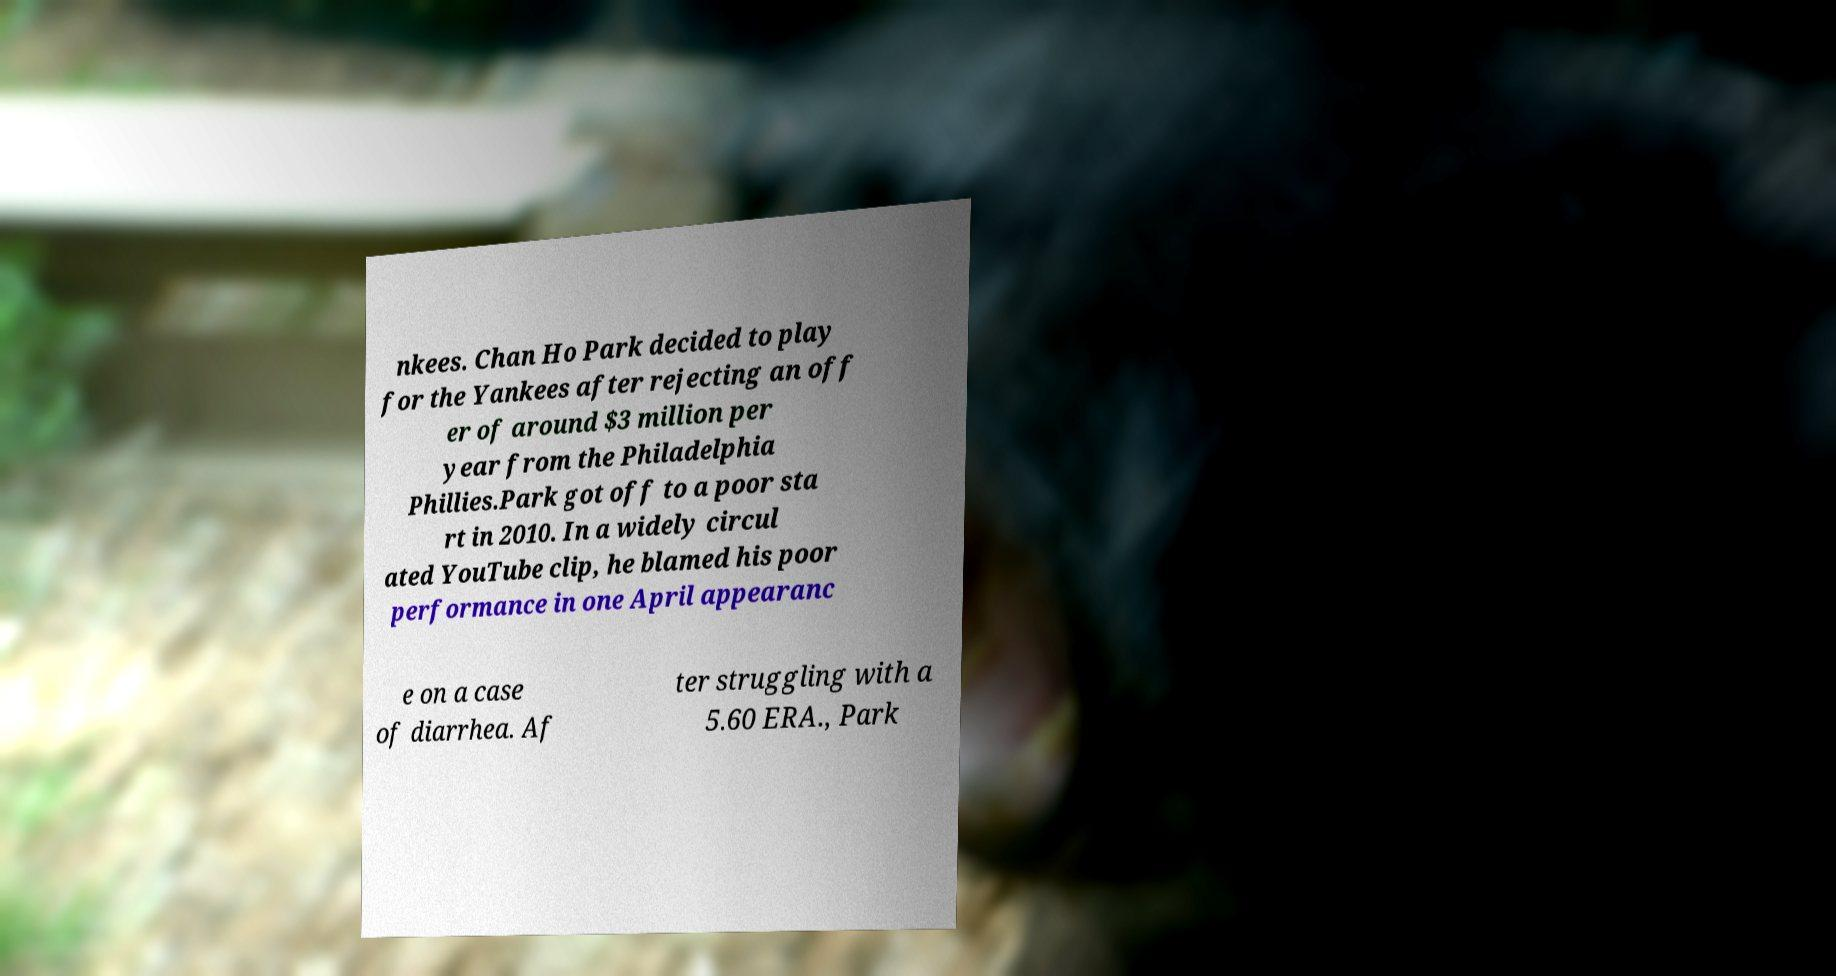For documentation purposes, I need the text within this image transcribed. Could you provide that? nkees. Chan Ho Park decided to play for the Yankees after rejecting an off er of around $3 million per year from the Philadelphia Phillies.Park got off to a poor sta rt in 2010. In a widely circul ated YouTube clip, he blamed his poor performance in one April appearanc e on a case of diarrhea. Af ter struggling with a 5.60 ERA., Park 